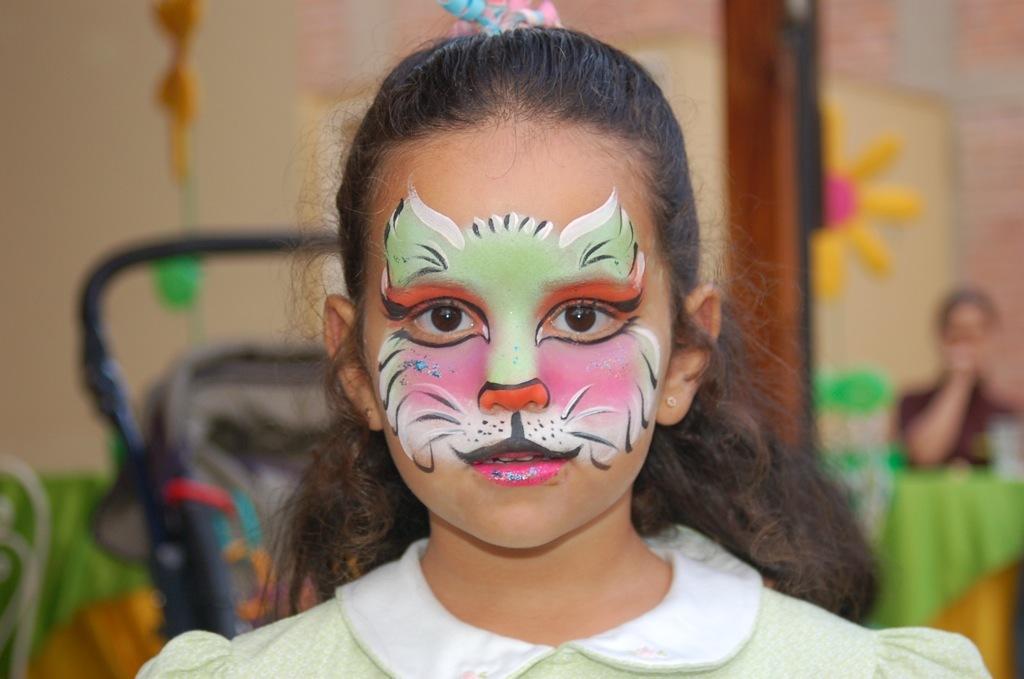Describe this image in one or two sentences. In this image there is a girl in the middle who has a painting on her face. In the background there is a person on the right side. On the left side there is a wall. Behind the girl there is a trolley. 